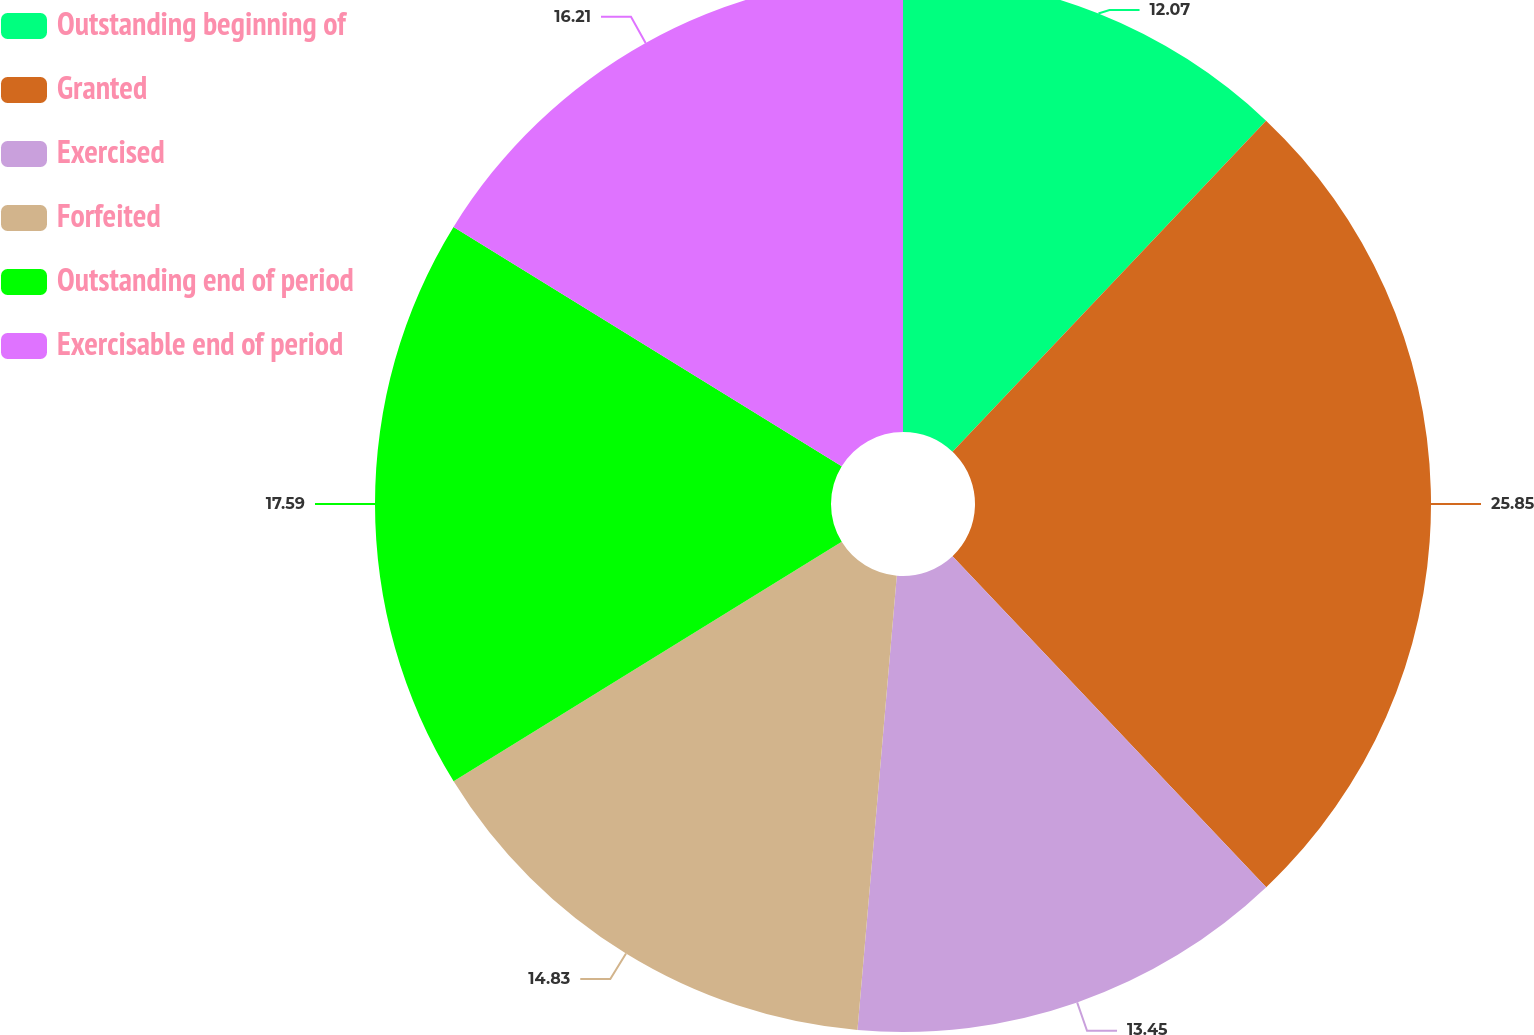<chart> <loc_0><loc_0><loc_500><loc_500><pie_chart><fcel>Outstanding beginning of<fcel>Granted<fcel>Exercised<fcel>Forfeited<fcel>Outstanding end of period<fcel>Exercisable end of period<nl><fcel>12.07%<fcel>25.86%<fcel>13.45%<fcel>14.83%<fcel>17.59%<fcel>16.21%<nl></chart> 